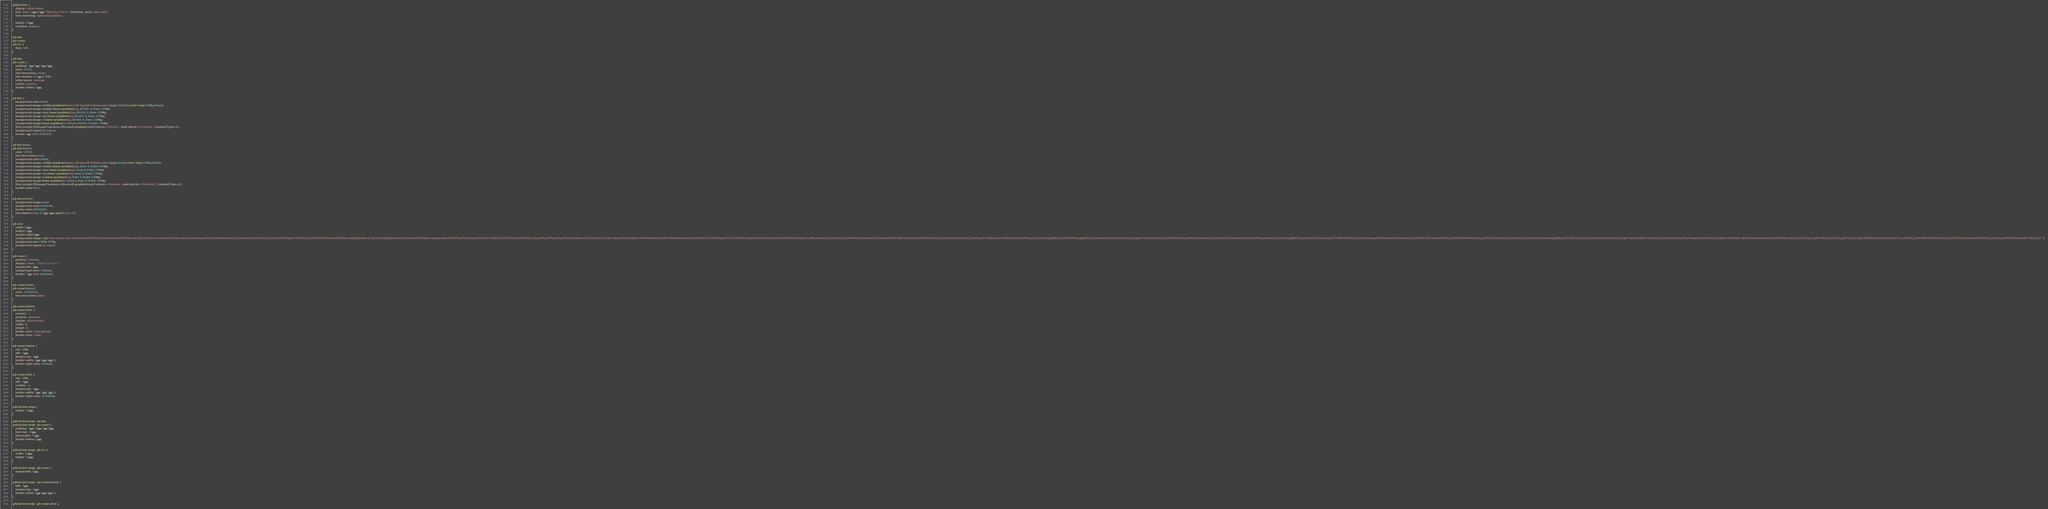Convert code to text. <code><loc_0><loc_0><loc_500><loc_500><_CSS_>.github-btn {
    display: inline-block;
    font: bold 11px/14px "Helvetica Neue", Helvetica, Arial, sans-serif;
    text-rendering: optimizeLegibility;

    height: 20px;
    overflow: hidden;
}

.gh-btn,
.gh-count,
.gh-ico {
    float: left;
}

.gh-btn,
.gh-count {
    padding: 2px 5px 2px 4px;
    color: #333;
    text-decoration: none;
    text-shadow: 0 1px 0 #fff;
    white-space: nowrap;
    cursor: pointer;
    border-radius: 3px;
}

.gh-btn {
	background-color:#eee;
	background-image:-webkit-gradient(linear,left top,left bottom,color-stop(0,#fcfcfc),color-stop(100%,#eee));
	background-image:-webkit-linear-gradient(top,#fcfcfc 0,#eee 100%);
	background-image:-moz-linear-gradient(top,#fcfcfc 0,#eee 100%);
	background-image:-ms-linear-gradient(top,#fcfcfc 0,#eee 100%);
	background-image:-o-linear-gradient(top,#fcfcfc 0,#eee 100%);
	background-image:linear-gradient(to bottom,#fcfcfc 0,#eee 100%);
	filter:progid:DXImageTransform.Microsoft.gradient(startColorstr='#fcfcfc', endColorstr='#eeeeee', GradientType=0);
	background-repeat:no-repeat;
	border:1px solid #d5d5d5
}

.gh-btn:focus,
.gh-btn:hover{
	color: #333;
	text-decoration:none;
	background-color:#ddd;
	background-image:-webkit-gradient(linear,left top,left bottom,color-stop(0,#eee),color-stop(100%,#ddd));
	background-image:-webkit-linear-gradient(top,#eee 0,#ddd 100%);
	background-image:-moz-linear-gradient(top,#eee 0,#ddd 100%);
	background-image:-ms-linear-gradient(top,#eee 0,#ddd 100%);
	background-image:-o-linear-gradient(top,#eee 0,#ddd 100%);
	background-image:linear-gradient(to bottom,#eee 0,#ddd 100%);
	filter:progid:DXImageTransform.Microsoft.gradient(startColorstr='#eeeeee', endColorstr='#dddddd', GradientType=0);
	border-color:#ccc
}

.gh-btn:active{
	background-image:none;
	background-color:#dcdcdc;
	border-color:#b5b5b5;
	box-shadow:inset 0 2px 4px rgba(0,0,0,.15)
}

.gh-ico{
	width:14px;
	height:14px;
	margin-right:4px;	
	background-image: url("data:image/svg+xml;base64,PHN2ZyB4bWxucz0iaHR0cDovL3d3dy53My5vcmcvMjAwMC9zdmciIHhtbG5zOnhsaW5rPSJodHRwOi8vd3d3LnczLm9yZy8xOTk5L3hsaW5rIiB2ZXJzaW9uPSIxLjEiIGlkPSJMYXllcl8xIiB4PSIwcHgiIHk9IjBweCIgd2lkdGg9IjQwcHgiIGhlaWdodD0iNDBweCIgdmlld0JveD0iMTIgMTIgNDAgNDAiIGVuYWJsZS1iYWNrZ3JvdW5kPSJuZXcgMTIgMTIgNDAgNDAiIHhtbDpzcGFjZT0icHJlc2VydmUiPjxwYXRoIGZpbGw9IiMzMzMzMzMiIGQ9Ik0zMiAxMy40Yy0xMC41IDAtMTkgOC41LTE5IDE5YzAgOC40IDUuNSAxNS41IDEzIDE4YzEgMC4yIDEuMy0wLjQgMS4zLTAuOWMwLTAuNSAwLTEuNyAwLTMuMiBjLTUuMyAxLjEtNi40LTIuNi02LjQtMi42QzIwIDQxLjYgMTguOCA0MSAxOC44IDQxYy0xLjctMS4yIDAuMS0xLjEgMC4xLTEuMWMxLjkgMC4xIDIuOSAyIDIuOSAyYzEuNyAyLjkgNC41IDIuMSA1LjUgMS42IGMwLjItMS4yIDAuNy0yLjEgMS4yLTIuNmMtNC4yLTAuNS04LjctMi4xLTguNy05LjRjMC0yLjEgMC43LTMuNyAyLTUuMWMtMC4yLTAuNS0wLjgtMi40IDAuMi01YzAgMCAxLjYtMC41IDUuMiAyIGMxLjUtMC40IDMuMS0wLjcgNC44LTAuN2MxLjYgMCAzLjMgMC4yIDQuNyAwLjdjMy42LTIuNCA1LjItMiA1LjItMmMxIDIuNiAwLjQgNC42IDAuMiA1YzEuMiAxLjMgMiAzIDIgNS4xYzAgNy4zLTQuNSA4LjktOC43IDkuNCBjMC43IDAuNiAxLjMgMS43IDEuMyAzLjVjMCAyLjYgMCA0LjYgMCA1LjJjMCAwLjUgMC40IDEuMSAxLjMgMC45YzcuNS0yLjYgMTMtOS43IDEzLTE4LjFDNTEgMjEuOSA0Mi41IDEzLjQgMzIgMTMuNHoiLz48L3N2Zz4=");
	background-size:100% 100%;
	background-repeat:no-repeat
}

.gh-count {
    position: relative;
    display: none; /* hidden to start */
    margin-left: 4px;
    background-color: #fafafa;
    border: 1px solid #d4d4d4;
}

.gh-count:hover,
.gh-count:focus {
    color: #4183C4;
	text-decoration:none;
}

.gh-count:before,
.gh-count:after {
    content: '';
    position: absolute;
    display: inline-block;
    width: 0;
    height: 0;
    border-color: transparent;
    border-style: solid;
}

.gh-count:before {
    top: 50%;
    left: -3px;
    margin-top: -4px;
    border-width: 4px 4px 4px 0;
    border-right-color: #fafafa;
}

.gh-count:after {
    top: 50%;
    left: -4px;
    z-index: -1;
    margin-top: -5px;
    border-width: 5px 5px 5px 0;
    border-right-color: #d4d4d4;
}

.github-btn-large {
    height: 30px;
}

.github-btn-large .gh-btn,
.github-btn-large .gh-count {
    padding: 3px 10px 3px 8px;
    font-size: 16px;
    line-height: 22px;
    border-radius: 4px;
}

.github-btn-large .gh-ico {
    width: 20px;
    height: 20px;
}

.github-btn-large .gh-count {
    margin-left: 6px;
}

.github-btn-large .gh-count:before {
    left: -5px;
    margin-top: -6px;
    border-width: 6px 6px 6px 0;
}

.github-btn-large .gh-count:after {</code> 